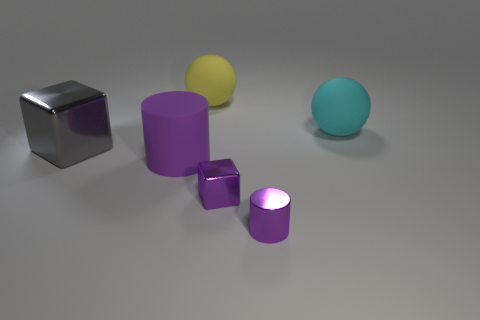Add 1 purple rubber cubes. How many objects exist? 7 Subtract all cubes. How many objects are left? 4 Subtract all matte cylinders. Subtract all big yellow rubber objects. How many objects are left? 4 Add 1 gray blocks. How many gray blocks are left? 2 Add 4 large cylinders. How many large cylinders exist? 5 Subtract 0 blue cylinders. How many objects are left? 6 